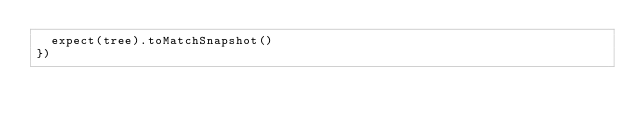Convert code to text. <code><loc_0><loc_0><loc_500><loc_500><_JavaScript_>  expect(tree).toMatchSnapshot()
})
</code> 